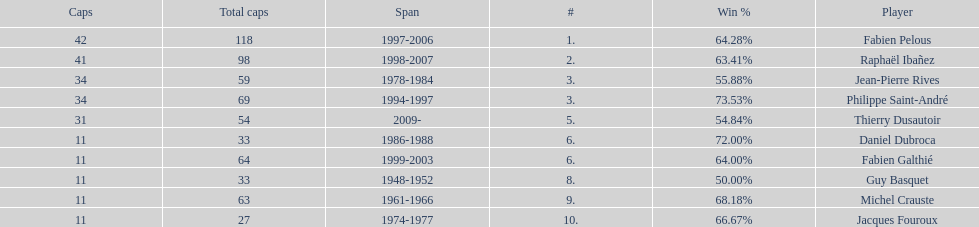How many caps did guy basquet accrue during his career? 33. 